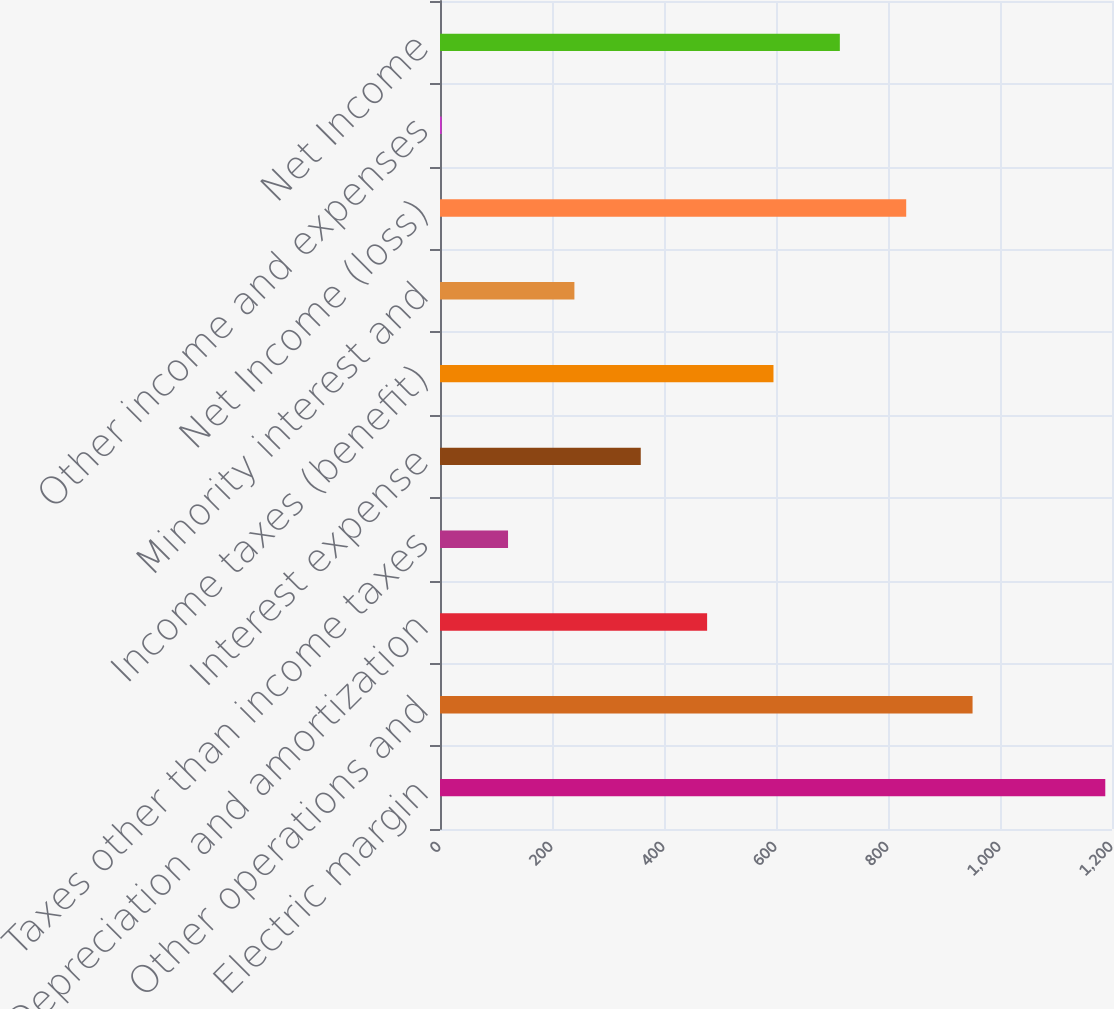Convert chart. <chart><loc_0><loc_0><loc_500><loc_500><bar_chart><fcel>Electric margin<fcel>Other operations and<fcel>Depreciation and amortization<fcel>Taxes other than income taxes<fcel>Interest expense<fcel>Income taxes (benefit)<fcel>Minority interest and<fcel>Net Income (loss)<fcel>Other income and expenses<fcel>Net Income<nl><fcel>1188<fcel>951<fcel>477<fcel>121.5<fcel>358.5<fcel>595.5<fcel>240<fcel>832.5<fcel>3<fcel>714<nl></chart> 